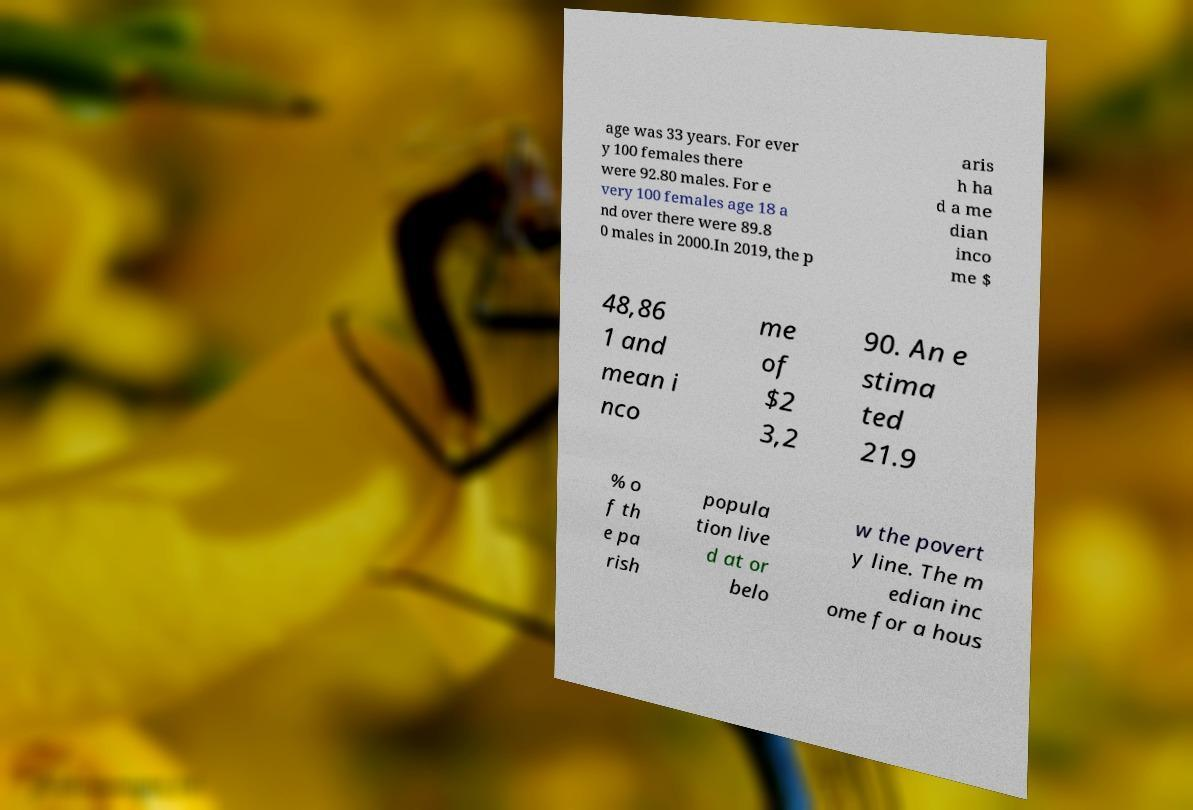Could you extract and type out the text from this image? age was 33 years. For ever y 100 females there were 92.80 males. For e very 100 females age 18 a nd over there were 89.8 0 males in 2000.In 2019, the p aris h ha d a me dian inco me $ 48,86 1 and mean i nco me of $2 3,2 90. An e stima ted 21.9 % o f th e pa rish popula tion live d at or belo w the povert y line. The m edian inc ome for a hous 